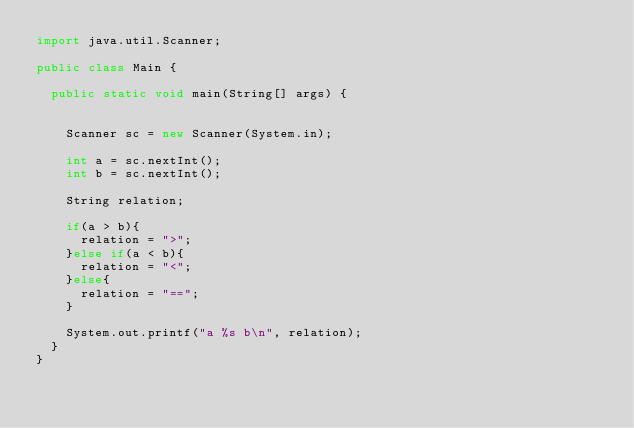<code> <loc_0><loc_0><loc_500><loc_500><_Java_>import java.util.Scanner;

public class Main {

	public static void main(String[] args) {


		Scanner sc = new Scanner(System.in);

		int a = sc.nextInt();
		int b = sc.nextInt();

		String relation;

		if(a > b){
			relation = ">";
		}else if(a < b){
			relation = "<";
		}else{
			relation = "==";
		}

		System.out.printf("a %s b\n", relation);
	}
}


</code> 